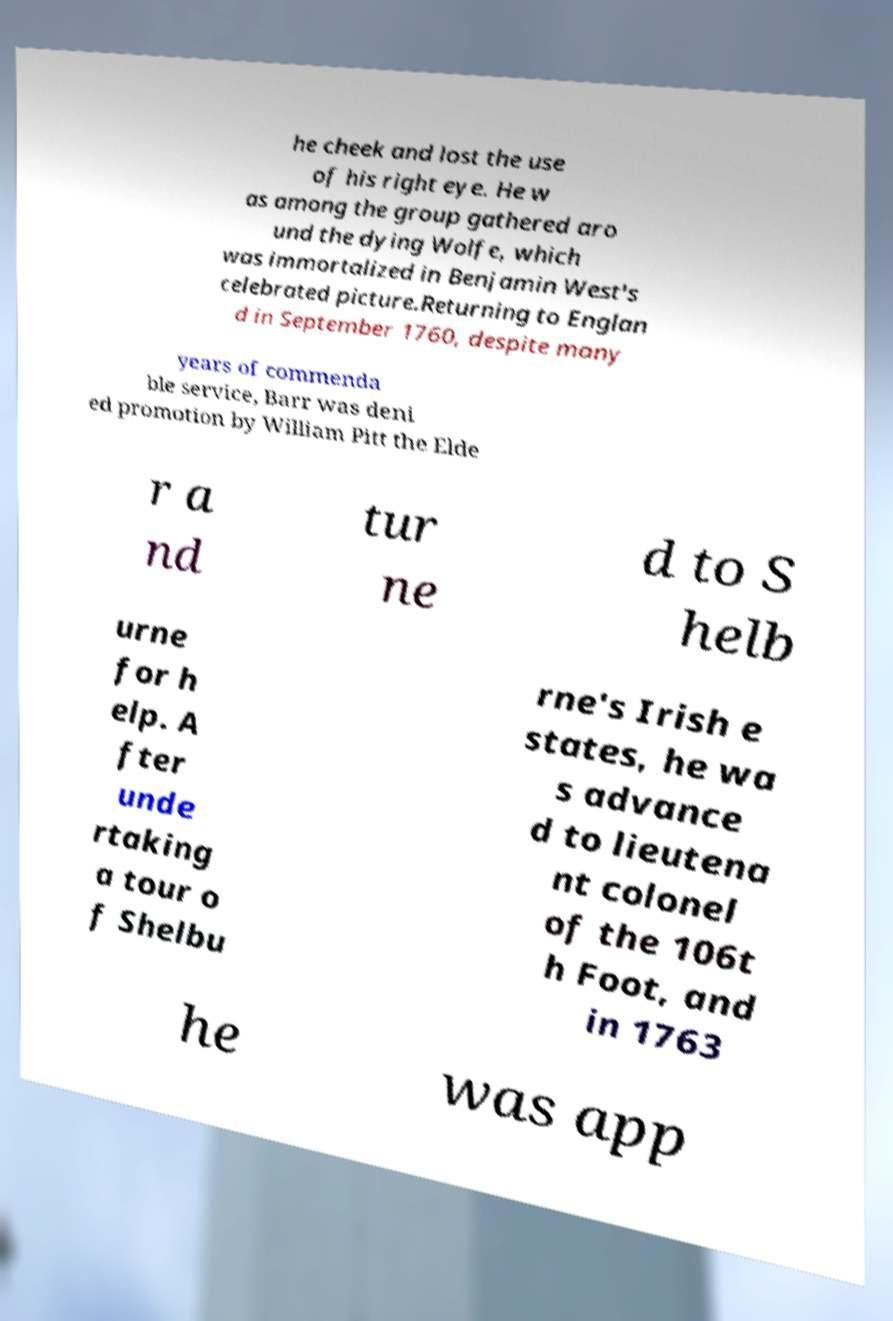I need the written content from this picture converted into text. Can you do that? he cheek and lost the use of his right eye. He w as among the group gathered aro und the dying Wolfe, which was immortalized in Benjamin West's celebrated picture.Returning to Englan d in September 1760, despite many years of commenda ble service, Barr was deni ed promotion by William Pitt the Elde r a nd tur ne d to S helb urne for h elp. A fter unde rtaking a tour o f Shelbu rne's Irish e states, he wa s advance d to lieutena nt colonel of the 106t h Foot, and in 1763 he was app 